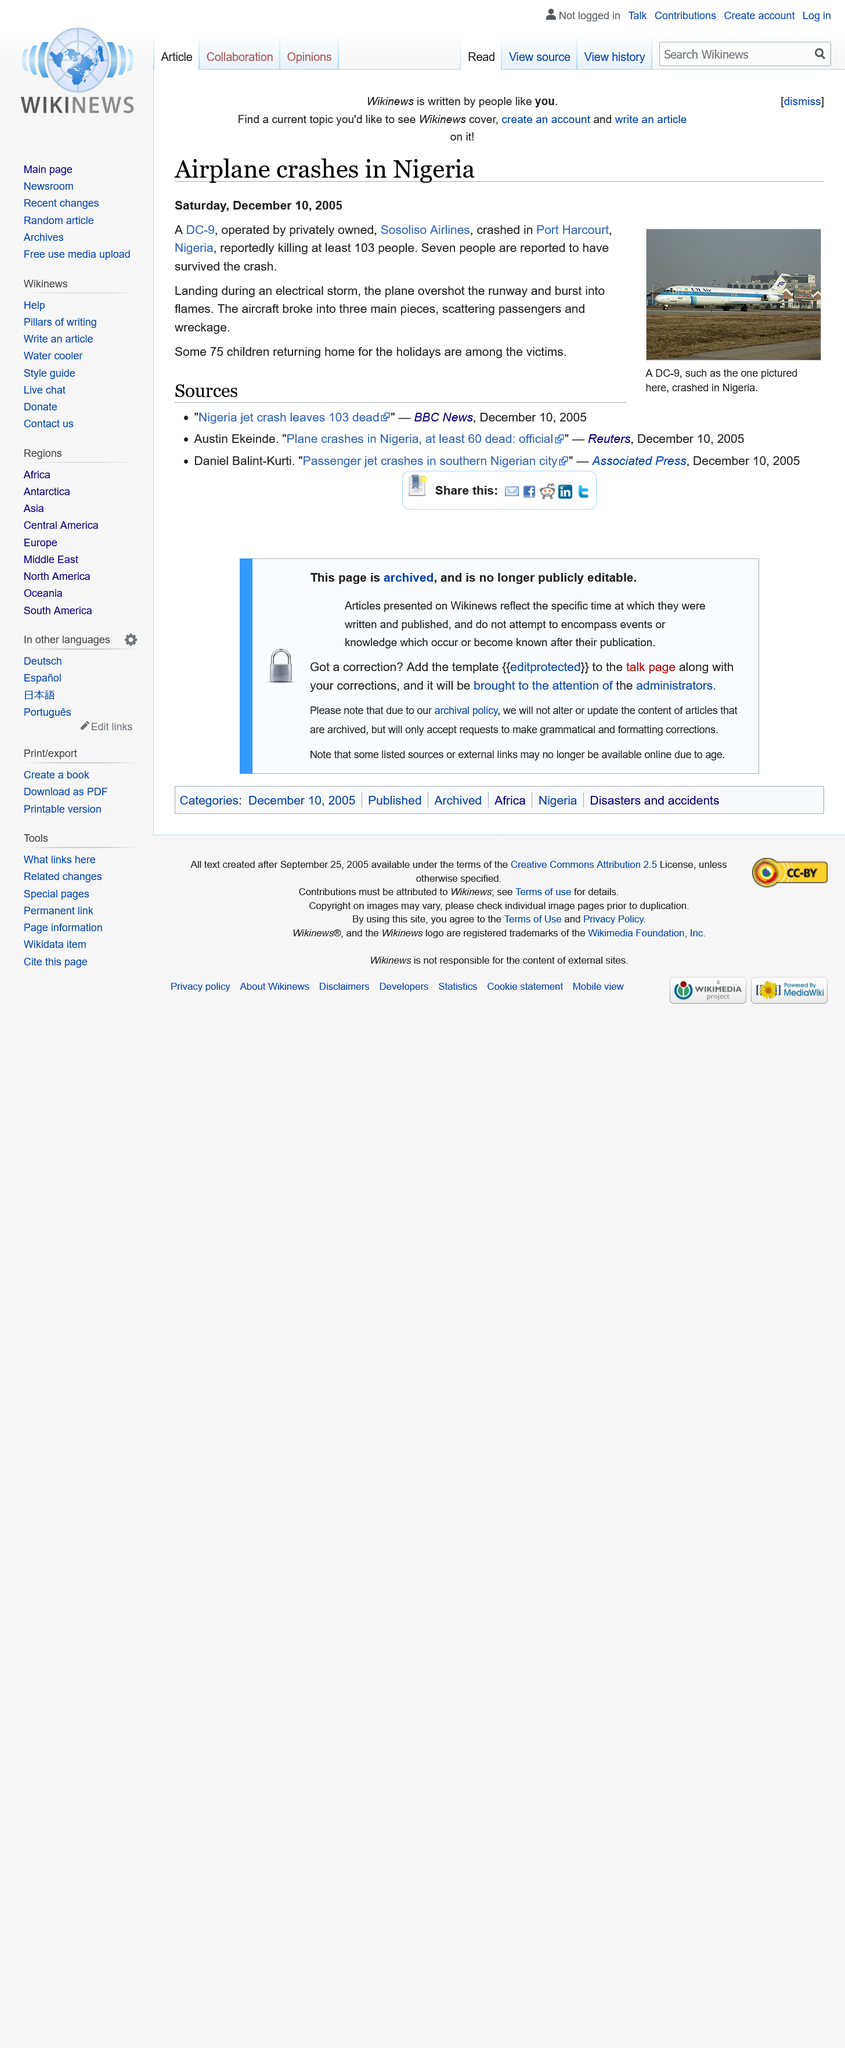Outline some significant characteristics in this image. The plane was landing due to an electrical storm. All 103 people on board the Sosoliso Airlines crash were killed, and of those who lost their lives, 75 were children. This article discusses airplane crashes that occurred in Nigeria and another country. 